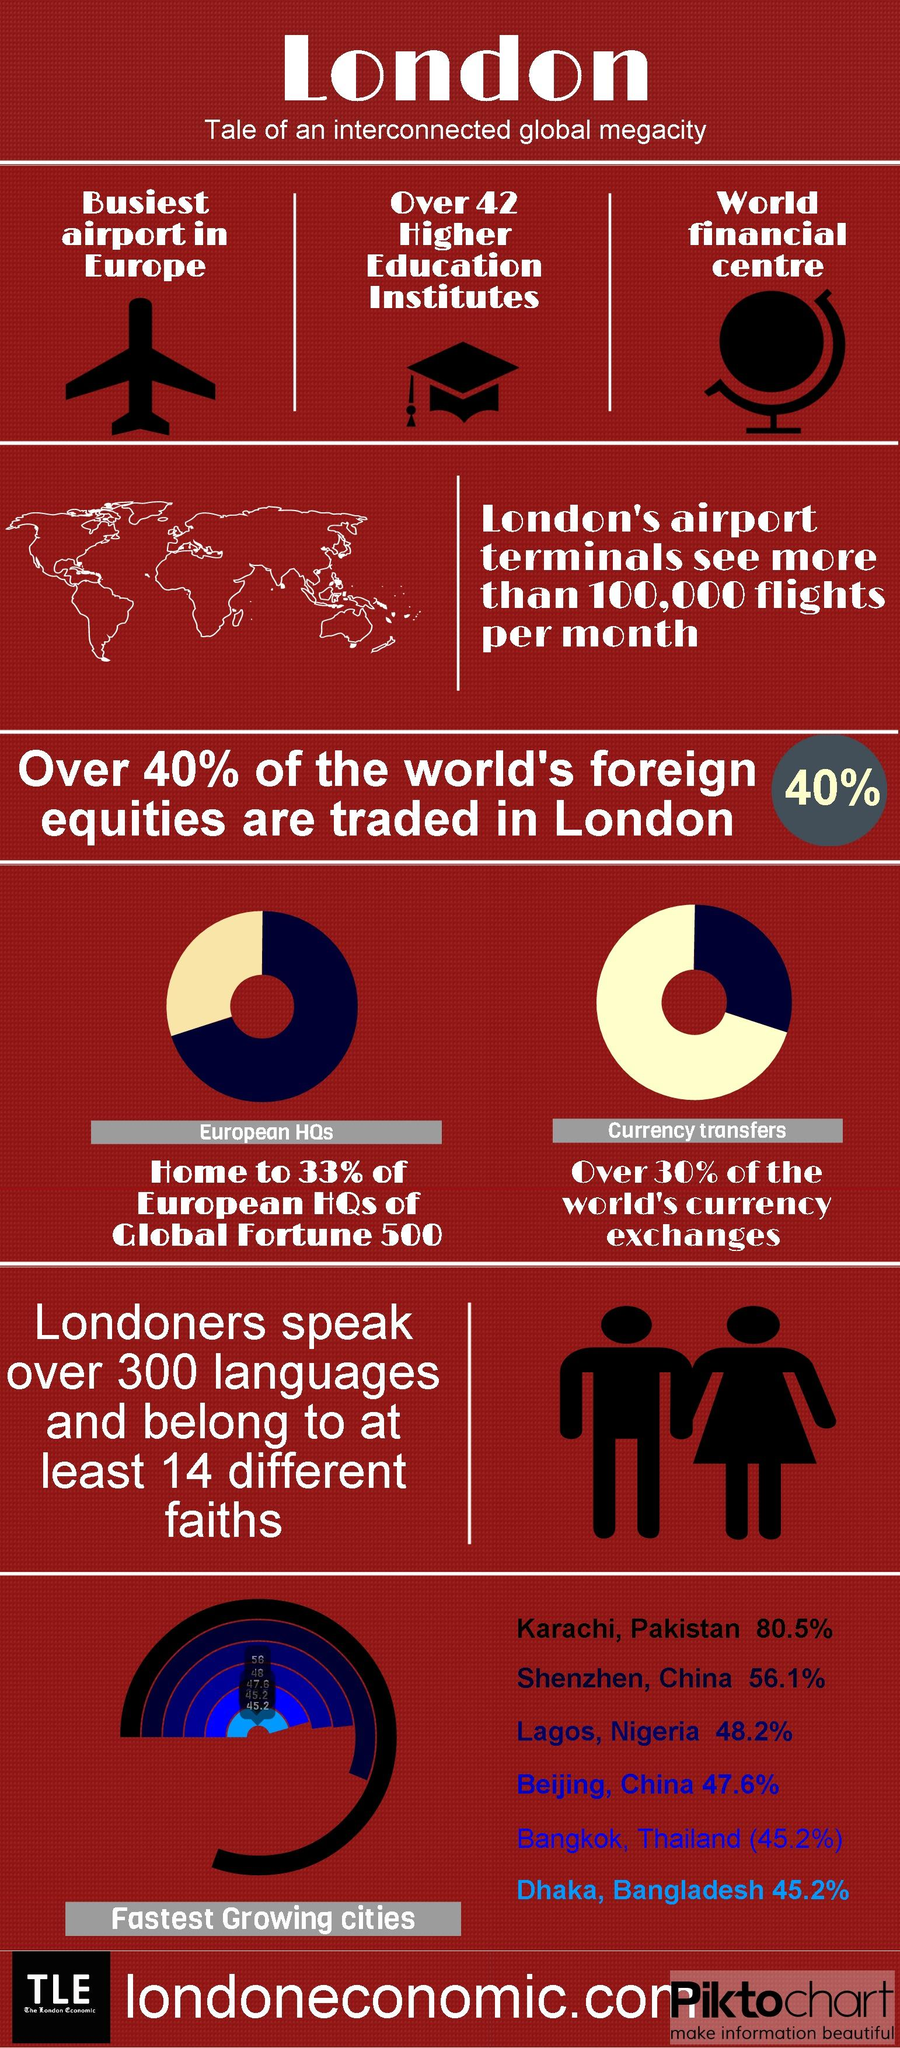Identify some key points in this picture. A significant percentage, 67%, of European headquarters are located outside of London. The number of airplane icons in this infographic is one. The third fastest-growing city in the world is Lagos, Nigeria. Approximately 60% of the world's foreign equity is traded outside of London. According to recent data, over 70% of the world's currency exchanges take place outside of London. 